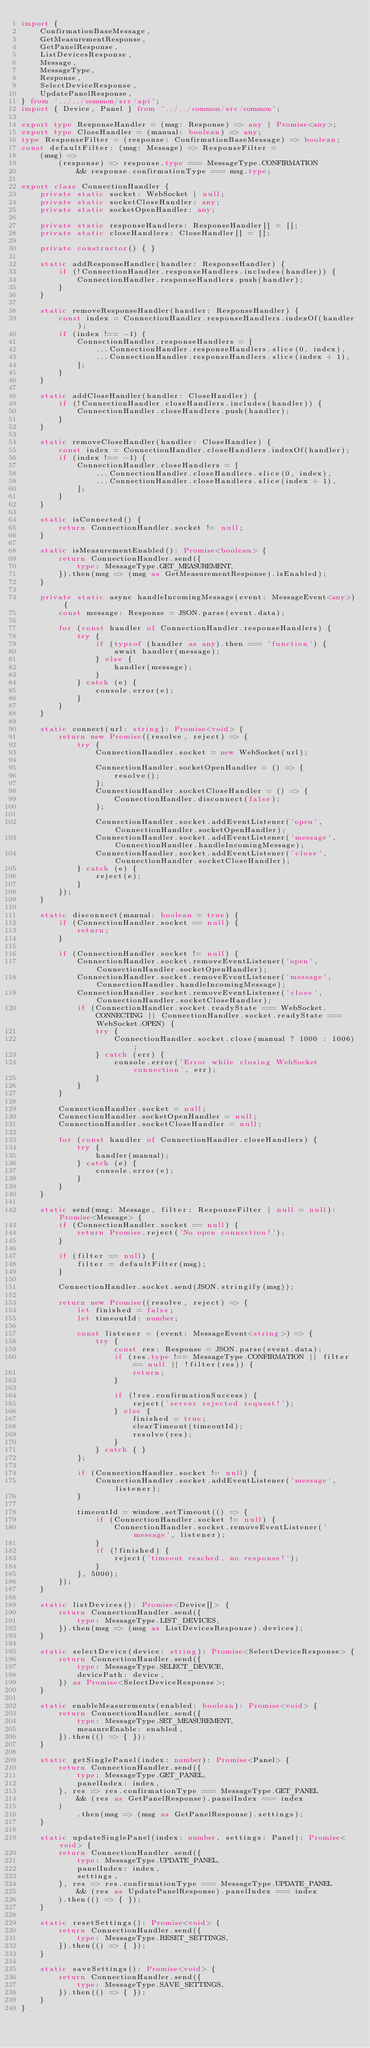Convert code to text. <code><loc_0><loc_0><loc_500><loc_500><_TypeScript_>import {
    ConfirmationBaseMessage,
    GetMeasurementResponse,
    GetPanelResponse,
    ListDevicesResponse,
    Message,
    MessageType,
    Response,
    SelectDeviceResponse,
    UpdatePanelResponse,
} from '../../common/src/api';
import { Device, Panel } from '../../common/src/common';

export type ResponseHandler = (msg: Response) => any | Promise<any>;
export type CloseHandler = (manual: boolean) => any;
type ResponseFilter = (response: ConfirmationBaseMessage) => boolean;
const defaultFilter: (msg: Message) => ResponseFilter =
    (msg) =>
        (response) => response.type === MessageType.CONFIRMATION
            && response.confirmationType === msg.type;

export class ConnectionHandler {
    private static socket: WebSocket | null;
    private static socketCloseHandler: any;
    private static socketOpenHandler: any;

    private static responseHandlers: ResponseHandler[] = [];
    private static closeHandlers: CloseHandler[] = [];

    private constructor() { }

    static addResponseHandler(handler: ResponseHandler) {
        if (!ConnectionHandler.responseHandlers.includes(handler)) {
            ConnectionHandler.responseHandlers.push(handler);
        }
    }

    static removeResponseHandler(handler: ResponseHandler) {
        const index = ConnectionHandler.responseHandlers.indexOf(handler);
        if (index !== -1) {
            ConnectionHandler.responseHandlers = [
                ...ConnectionHandler.responseHandlers.slice(0, index),
                ...ConnectionHandler.responseHandlers.slice(index + 1),
            ];
        }
    }

    static addCloseHandler(handler: CloseHandler) {
        if (!ConnectionHandler.closeHandlers.includes(handler)) {
            ConnectionHandler.closeHandlers.push(handler);
        }
    }

    static removeCloseHandler(handler: CloseHandler) {
        const index = ConnectionHandler.closeHandlers.indexOf(handler);
        if (index !== -1) {
            ConnectionHandler.closeHandlers = [
                ...ConnectionHandler.closeHandlers.slice(0, index),
                ...ConnectionHandler.closeHandlers.slice(index + 1),
            ];
        }
    }

    static isConnected() {
        return ConnectionHandler.socket != null;
    }

    static isMeasurementEnabled(): Promise<boolean> {
        return ConnectionHandler.send({
            type: MessageType.GET_MEASUREMENT,
        }).then(msg => (msg as GetMeasurementResponse).isEnabled);
    }

    private static async handleIncomingMessage(event: MessageEvent<any>) {
        const message: Response = JSON.parse(event.data);

        for (const handler of ConnectionHandler.responseHandlers) {
            try {
                if (typeof (handler as any).then === 'function') {
                    await handler(message);
                } else {
                    handler(message);
                }
            } catch (e) {
                console.error(e);
            }
        }
    }

    static connect(url: string): Promise<void> {
        return new Promise((resolve, reject) => {
            try {
                ConnectionHandler.socket = new WebSocket(url);

                ConnectionHandler.socketOpenHandler = () => {
                    resolve();
                };
                ConnectionHandler.socketCloseHandler = () => {
                    ConnectionHandler.disconnect(false);
                };

                ConnectionHandler.socket.addEventListener('open', ConnectionHandler.socketOpenHandler);
                ConnectionHandler.socket.addEventListener('message', ConnectionHandler.handleIncomingMessage);
                ConnectionHandler.socket.addEventListener('close', ConnectionHandler.socketCloseHandler);
            } catch (e) {
                reject(e);
            }
        });
    }

    static disconnect(manual: boolean = true) {
        if (ConnectionHandler.socket == null) {
            return;
        }

        if (ConnectionHandler.socket != null) {
            ConnectionHandler.socket.removeEventListener('open', ConnectionHandler.socketOpenHandler);
            ConnectionHandler.socket.removeEventListener('message', ConnectionHandler.handleIncomingMessage);
            ConnectionHandler.socket.removeEventListener('close', ConnectionHandler.socketCloseHandler);
            if (ConnectionHandler.socket.readyState === WebSocket.CONNECTING || ConnectionHandler.socket.readyState === WebSocket.OPEN) {
                try {
                    ConnectionHandler.socket.close(manual ? 1000 : 1006);
                } catch (err) {
                    console.error('Error while closing WebSocket connection', err);
                }
            }
        }

        ConnectionHandler.socket = null;
        ConnectionHandler.socketOpenHandler = null;
        ConnectionHandler.socketCloseHandler = null;

        for (const handler of ConnectionHandler.closeHandlers) {
            try {
                handler(manual);
            } catch (e) {
                console.error(e);
            }
        }
    }

    static send(msg: Message, filter: ResponseFilter | null = null): Promise<Message> {
        if (ConnectionHandler.socket == null) {
            return Promise.reject('No open connection!');
        }

        if (filter == null) {
            filter = defaultFilter(msg);
        }

        ConnectionHandler.socket.send(JSON.stringify(msg));

        return new Promise((resolve, reject) => {
            let finished = false;
            let timeoutId: number;

            const listener = (event: MessageEvent<string>) => {
                try {
                    const res: Response = JSON.parse(event.data);
                    if (res.type !== MessageType.CONFIRMATION || filter == null || !filter(res)) {
                        return;
                    }

                    if (!res.confirmationSuccess) {
                        reject('server rejected request!');
                    } else {
                        finished = true;
                        clearTimeout(timeoutId);
                        resolve(res);
                    }
                } catch { }
            };

            if (ConnectionHandler.socket != null) {
                ConnectionHandler.socket.addEventListener('message', listener);
            }

            timeoutId = window.setTimeout(() => {
                if (ConnectionHandler.socket != null) {
                    ConnectionHandler.socket.removeEventListener('message', listener);
                }
                if (!finished) {
                    reject('timeout reached, no response!');
                }
            }, 5000);
        });
    }

    static listDevices(): Promise<Device[]> {
        return ConnectionHandler.send({
            type: MessageType.LIST_DEVICES,
        }).then(msg => (msg as ListDevicesResponse).devices);
    }

    static selectDevice(device: string): Promise<SelectDeviceResponse> {
        return ConnectionHandler.send({
            type: MessageType.SELECT_DEVICE,
            devicePath: device,
        }) as Promise<SelectDeviceResponse>;
    }

    static enableMeasurements(enabled: boolean): Promise<void> {
        return ConnectionHandler.send({
            type: MessageType.SET_MEASUREMENT,
            measureEnable: enabled,
        }).then(() => { });
    }

    static getSinglePanel(index: number): Promise<Panel> {
        return ConnectionHandler.send({
            type: MessageType.GET_PANEL,
            panelIndex: index,
        }, res => res.confirmationType === MessageType.GET_PANEL
            && (res as GetPanelResponse).panelIndex === index
        )
            .then(msg => (msg as GetPanelResponse).settings);
    }

    static updateSinglePanel(index: number, settings: Panel): Promise<void> {
        return ConnectionHandler.send({
            type: MessageType.UPDATE_PANEL,
            panelIndex: index,
            settings,
        }, res => res.confirmationType === MessageType.UPDATE_PANEL
            && (res as UpdatePanelResponse).panelIndex === index
        ).then(() => { });
    }

    static resetSettings(): Promise<void> {
        return ConnectionHandler.send({
            type: MessageType.RESET_SETTINGS,
        }).then(() => { });
    }

    static saveSettings(): Promise<void> {
        return ConnectionHandler.send({
            type: MessageType.SAVE_SETTINGS,
        }).then(() => { });
    }
}</code> 